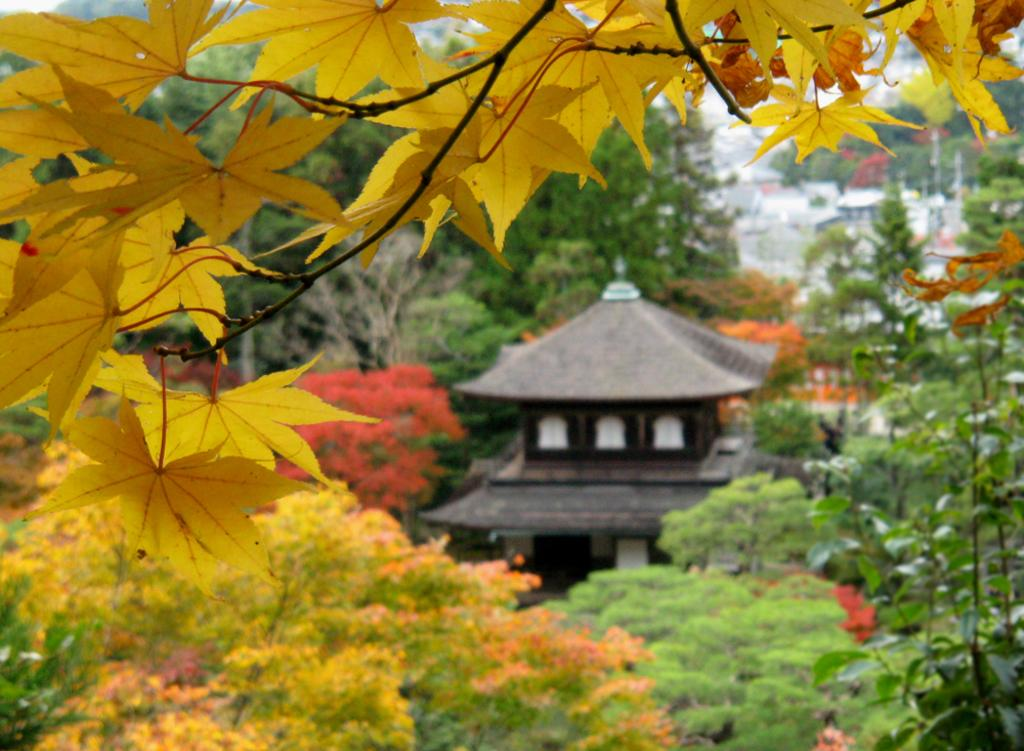What color are the leaves on the tree branch in the image? The leaves on the tree branch are yellow. What else can be seen in the image besides the tree branch? There are other trees visible in the background, and some architecture can be seen between the trees. What type of fowl can be seen starting a race in the image? There are no fowl or races present in the image; it features a tree branch with yellow leaves and other trees in the background. 